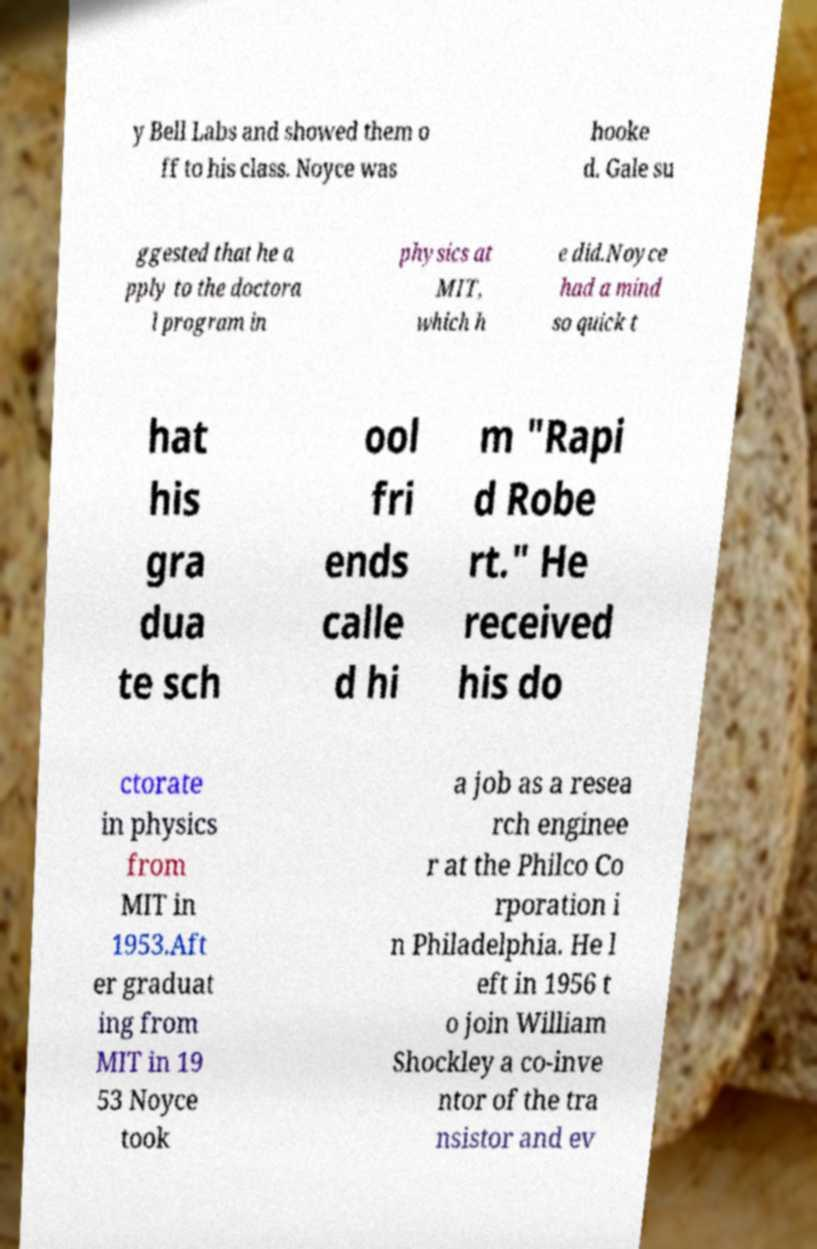Please identify and transcribe the text found in this image. y Bell Labs and showed them o ff to his class. Noyce was hooke d. Gale su ggested that he a pply to the doctora l program in physics at MIT, which h e did.Noyce had a mind so quick t hat his gra dua te sch ool fri ends calle d hi m "Rapi d Robe rt." He received his do ctorate in physics from MIT in 1953.Aft er graduat ing from MIT in 19 53 Noyce took a job as a resea rch enginee r at the Philco Co rporation i n Philadelphia. He l eft in 1956 t o join William Shockley a co-inve ntor of the tra nsistor and ev 